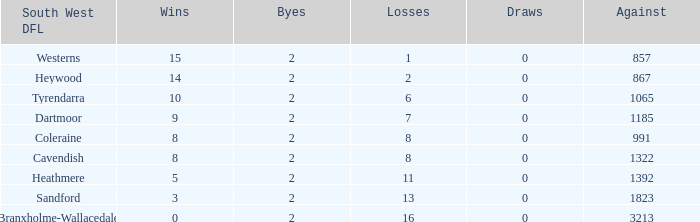Which Losses have a South West DFL of branxholme-wallacedale, and less than 2 Byes? None. 